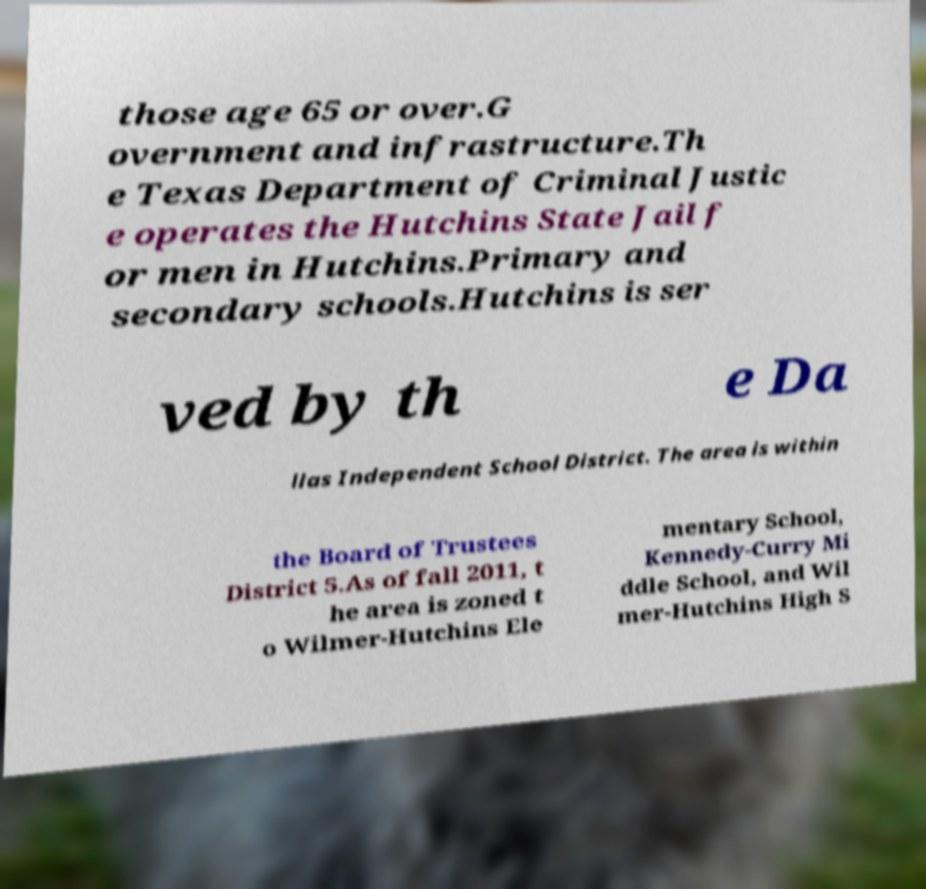Can you accurately transcribe the text from the provided image for me? those age 65 or over.G overnment and infrastructure.Th e Texas Department of Criminal Justic e operates the Hutchins State Jail f or men in Hutchins.Primary and secondary schools.Hutchins is ser ved by th e Da llas Independent School District. The area is within the Board of Trustees District 5.As of fall 2011, t he area is zoned t o Wilmer-Hutchins Ele mentary School, Kennedy-Curry Mi ddle School, and Wil mer-Hutchins High S 